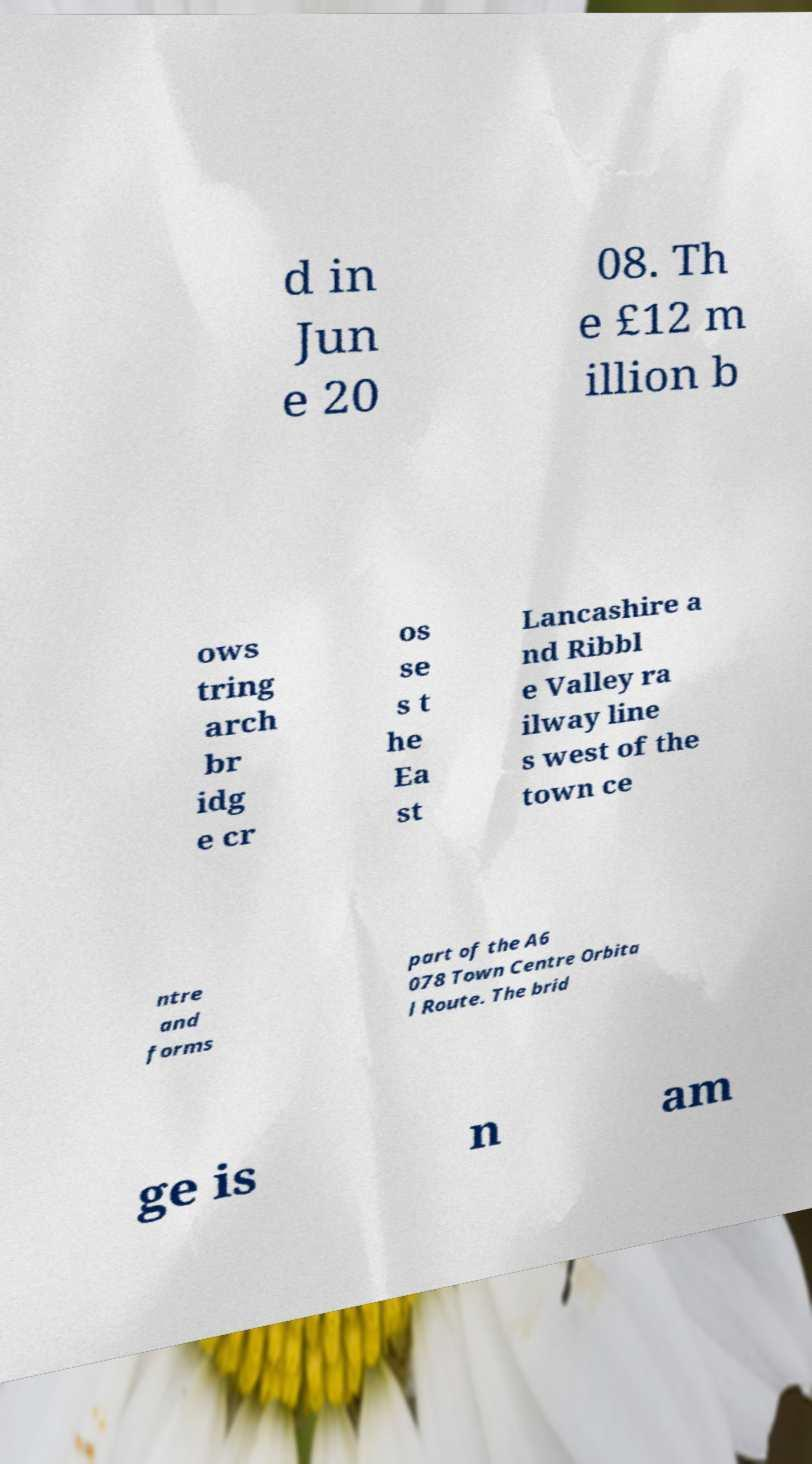Could you extract and type out the text from this image? d in Jun e 20 08. Th e £12 m illion b ows tring arch br idg e cr os se s t he Ea st Lancashire a nd Ribbl e Valley ra ilway line s west of the town ce ntre and forms part of the A6 078 Town Centre Orbita l Route. The brid ge is n am 